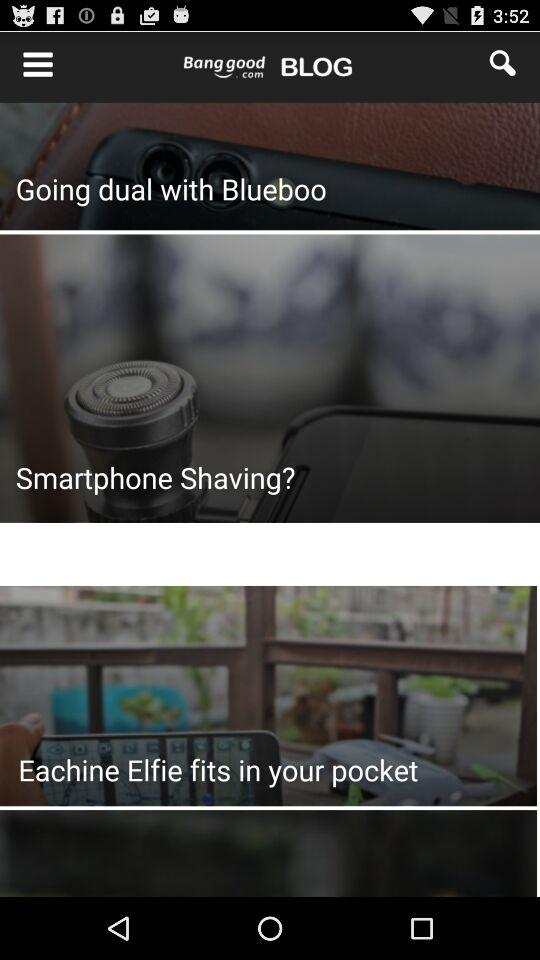What is the cost of the "Pet Nest Sleeping Warm Cushion"? The cost is US$14.25–16.75. 